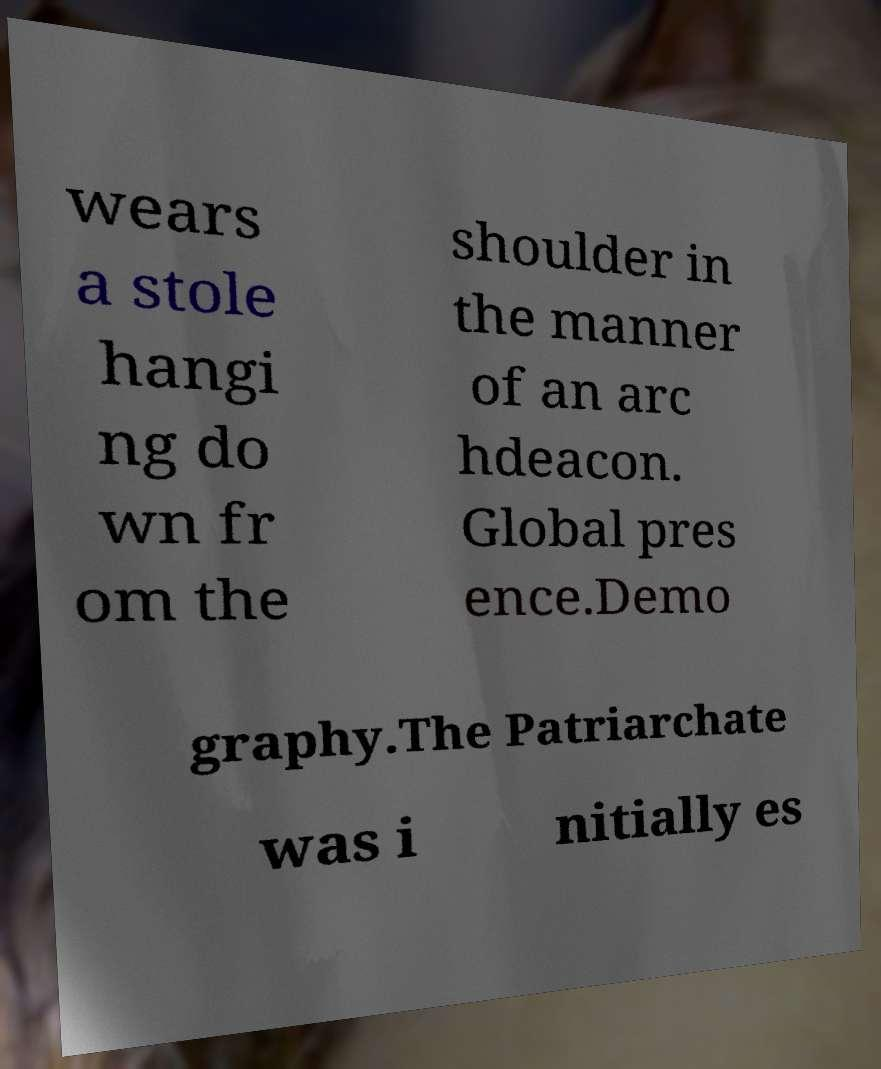Could you assist in decoding the text presented in this image and type it out clearly? wears a stole hangi ng do wn fr om the shoulder in the manner of an arc hdeacon. Global pres ence.Demo graphy.The Patriarchate was i nitially es 